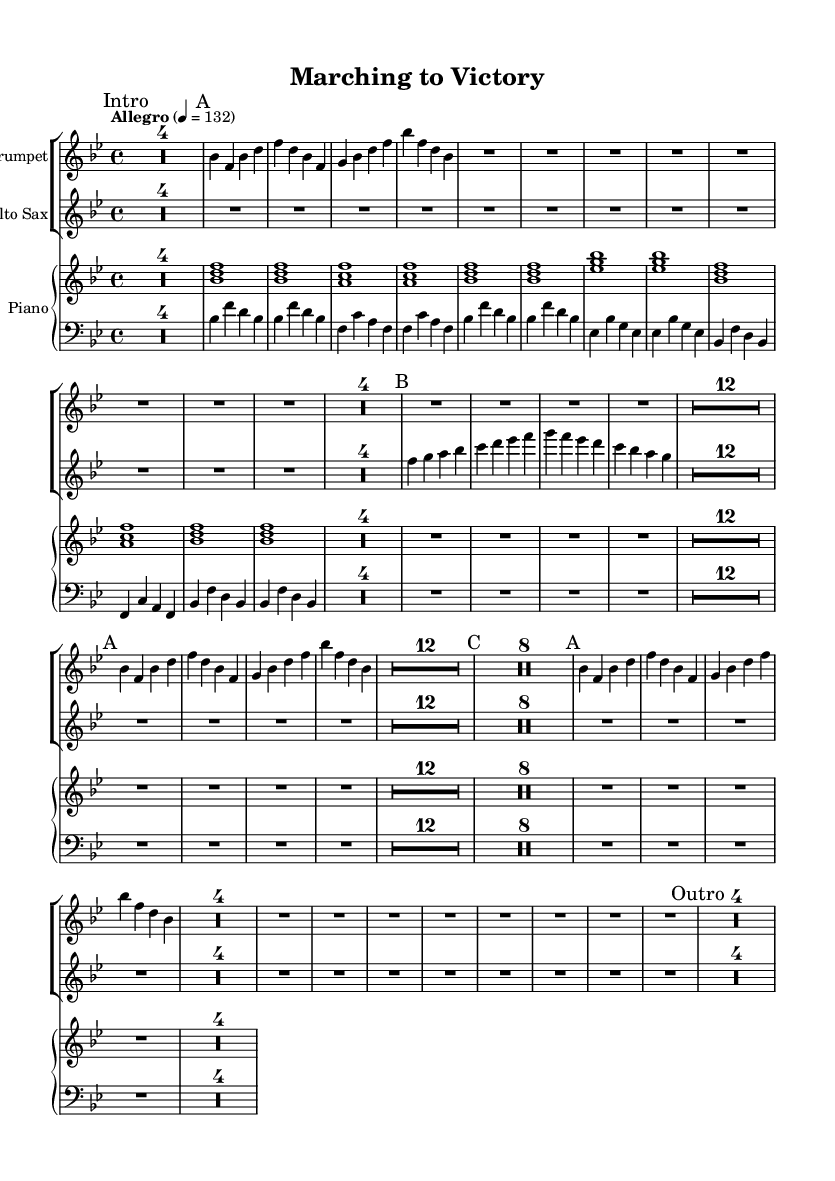What is the key signature of this music? The key signature is indicated at the beginning of the score, which is "bes" major. This means there are two flats in the key signature: B-flat and E-flat.
Answer: B-flat major What is the time signature of this music? The time signature is shown at the beginning of the sheet music as "4/4," meaning there are four beats in each measure and the quarter note receives one beat.
Answer: 4/4 What is the tempo marking for this piece? The tempo marking is found under the global settings, indicated as "Allegro" with a metronome marking of "4 = 132," meaning the music should be played quickly at 132 beats per minute.
Answer: Allegro, 132 How many measures are marked as "A"? By examining the sections marked "A," we see they appear three times in the music: during the first, fifth, and eighth measures, which indicates that there is a total of three measures marked as "A."
Answer: 3 What is the rhythm pattern mostly used in section "A"? The rhythm pattern in section "A" primarily consists of quarter notes, which are characterized by a steady and driving pulse fitting the style of big band swing music.
Answer: Quarter notes Which instruments are featured in this piece? The sheet music features a trumpet, an alto saxophone, and a piano, as indicated by the instrument names written at the top of each staff.
Answer: Trumpet, Alto Saxophone, Piano What style is this music reminiscent of? The music’s title and its precision in rhythms and ensemble playing indicate a style reminiscent of military marches, reflecting the discipline and teamwork often associated with such genres.
Answer: Military marches 